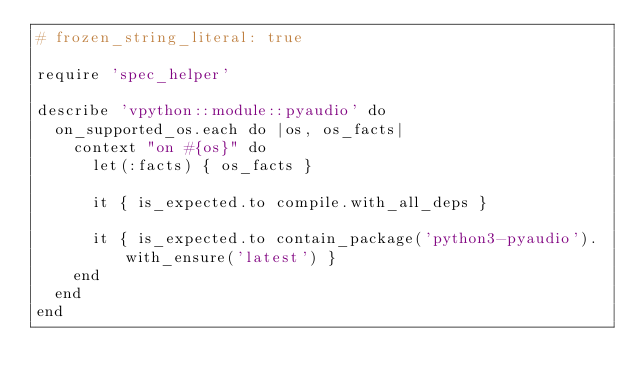Convert code to text. <code><loc_0><loc_0><loc_500><loc_500><_Ruby_># frozen_string_literal: true

require 'spec_helper'

describe 'vpython::module::pyaudio' do
  on_supported_os.each do |os, os_facts|
    context "on #{os}" do
      let(:facts) { os_facts }

      it { is_expected.to compile.with_all_deps }

      it { is_expected.to contain_package('python3-pyaudio').with_ensure('latest') }
    end
  end
end
</code> 